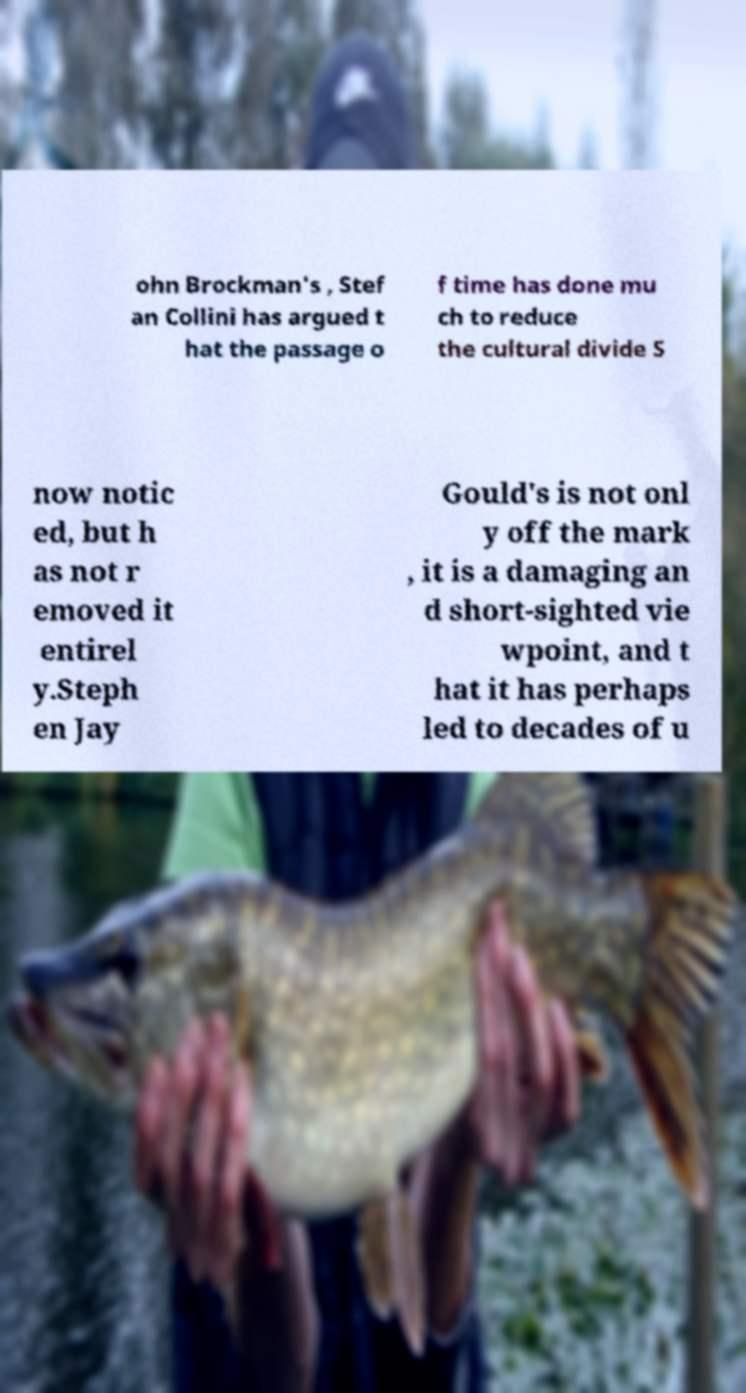Could you extract and type out the text from this image? ohn Brockman's , Stef an Collini has argued t hat the passage o f time has done mu ch to reduce the cultural divide S now notic ed, but h as not r emoved it entirel y.Steph en Jay Gould's is not onl y off the mark , it is a damaging an d short-sighted vie wpoint, and t hat it has perhaps led to decades of u 